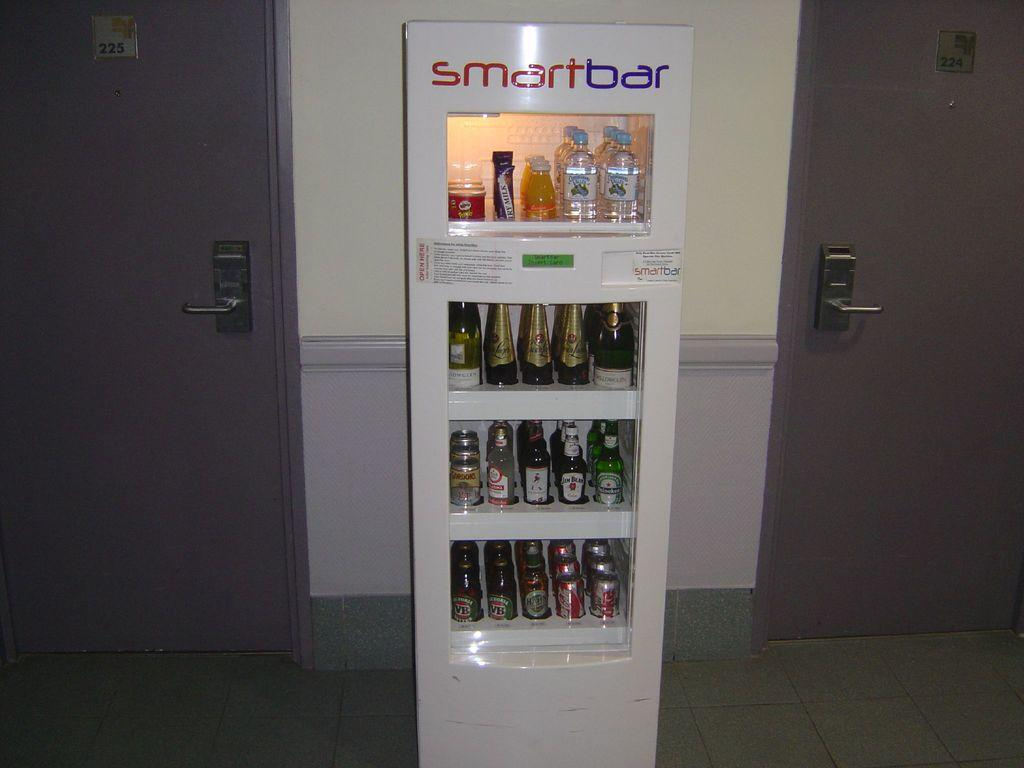Provide a one-sentence caption for the provided image. a SMART BAR vending machine with various drinks for sale. 